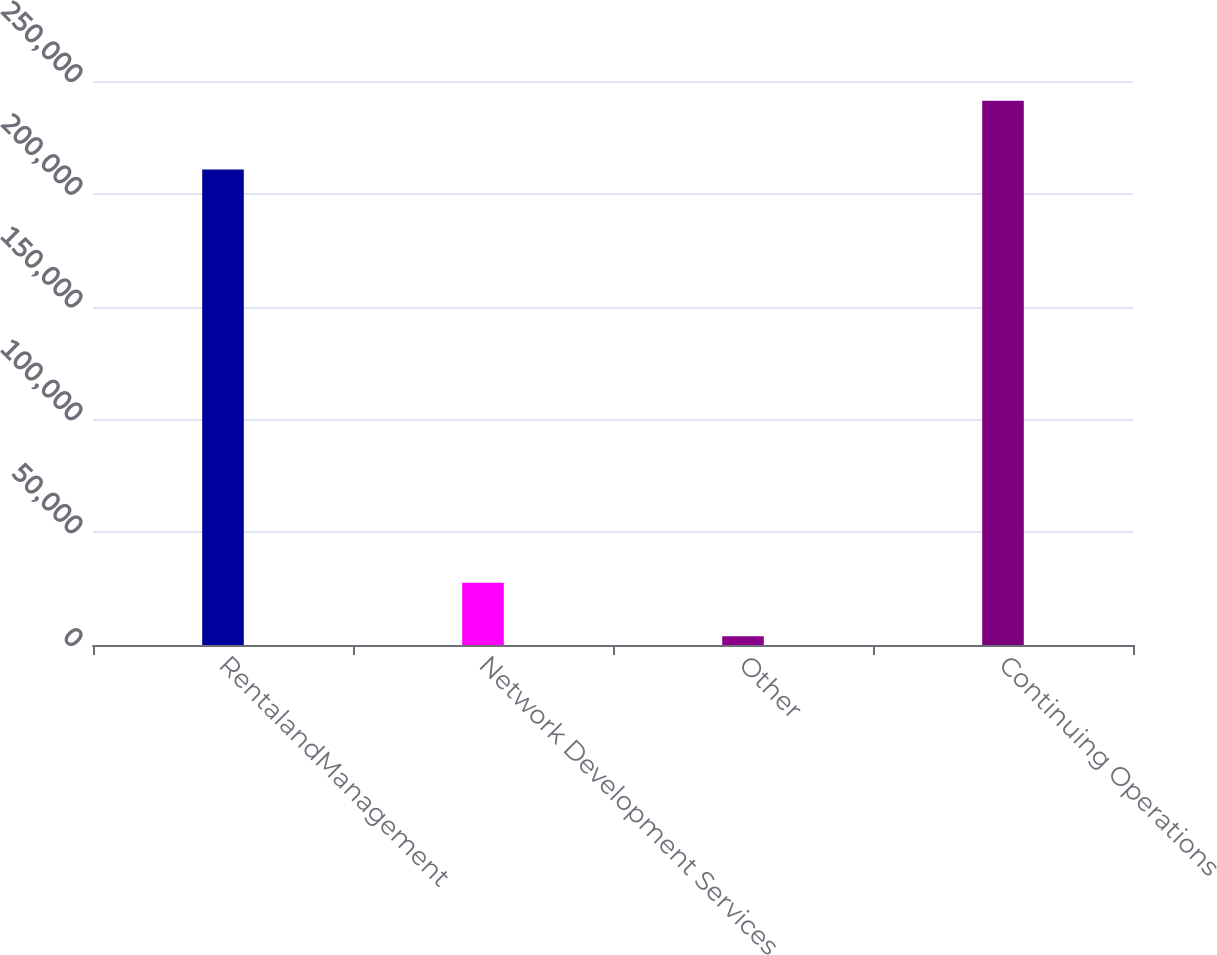Convert chart to OTSL. <chart><loc_0><loc_0><loc_500><loc_500><bar_chart><fcel>RentalandManagement<fcel>Network Development Services<fcel>Other<fcel>Continuing Operations<nl><fcel>210816<fcel>27573.5<fcel>3836<fcel>241211<nl></chart> 